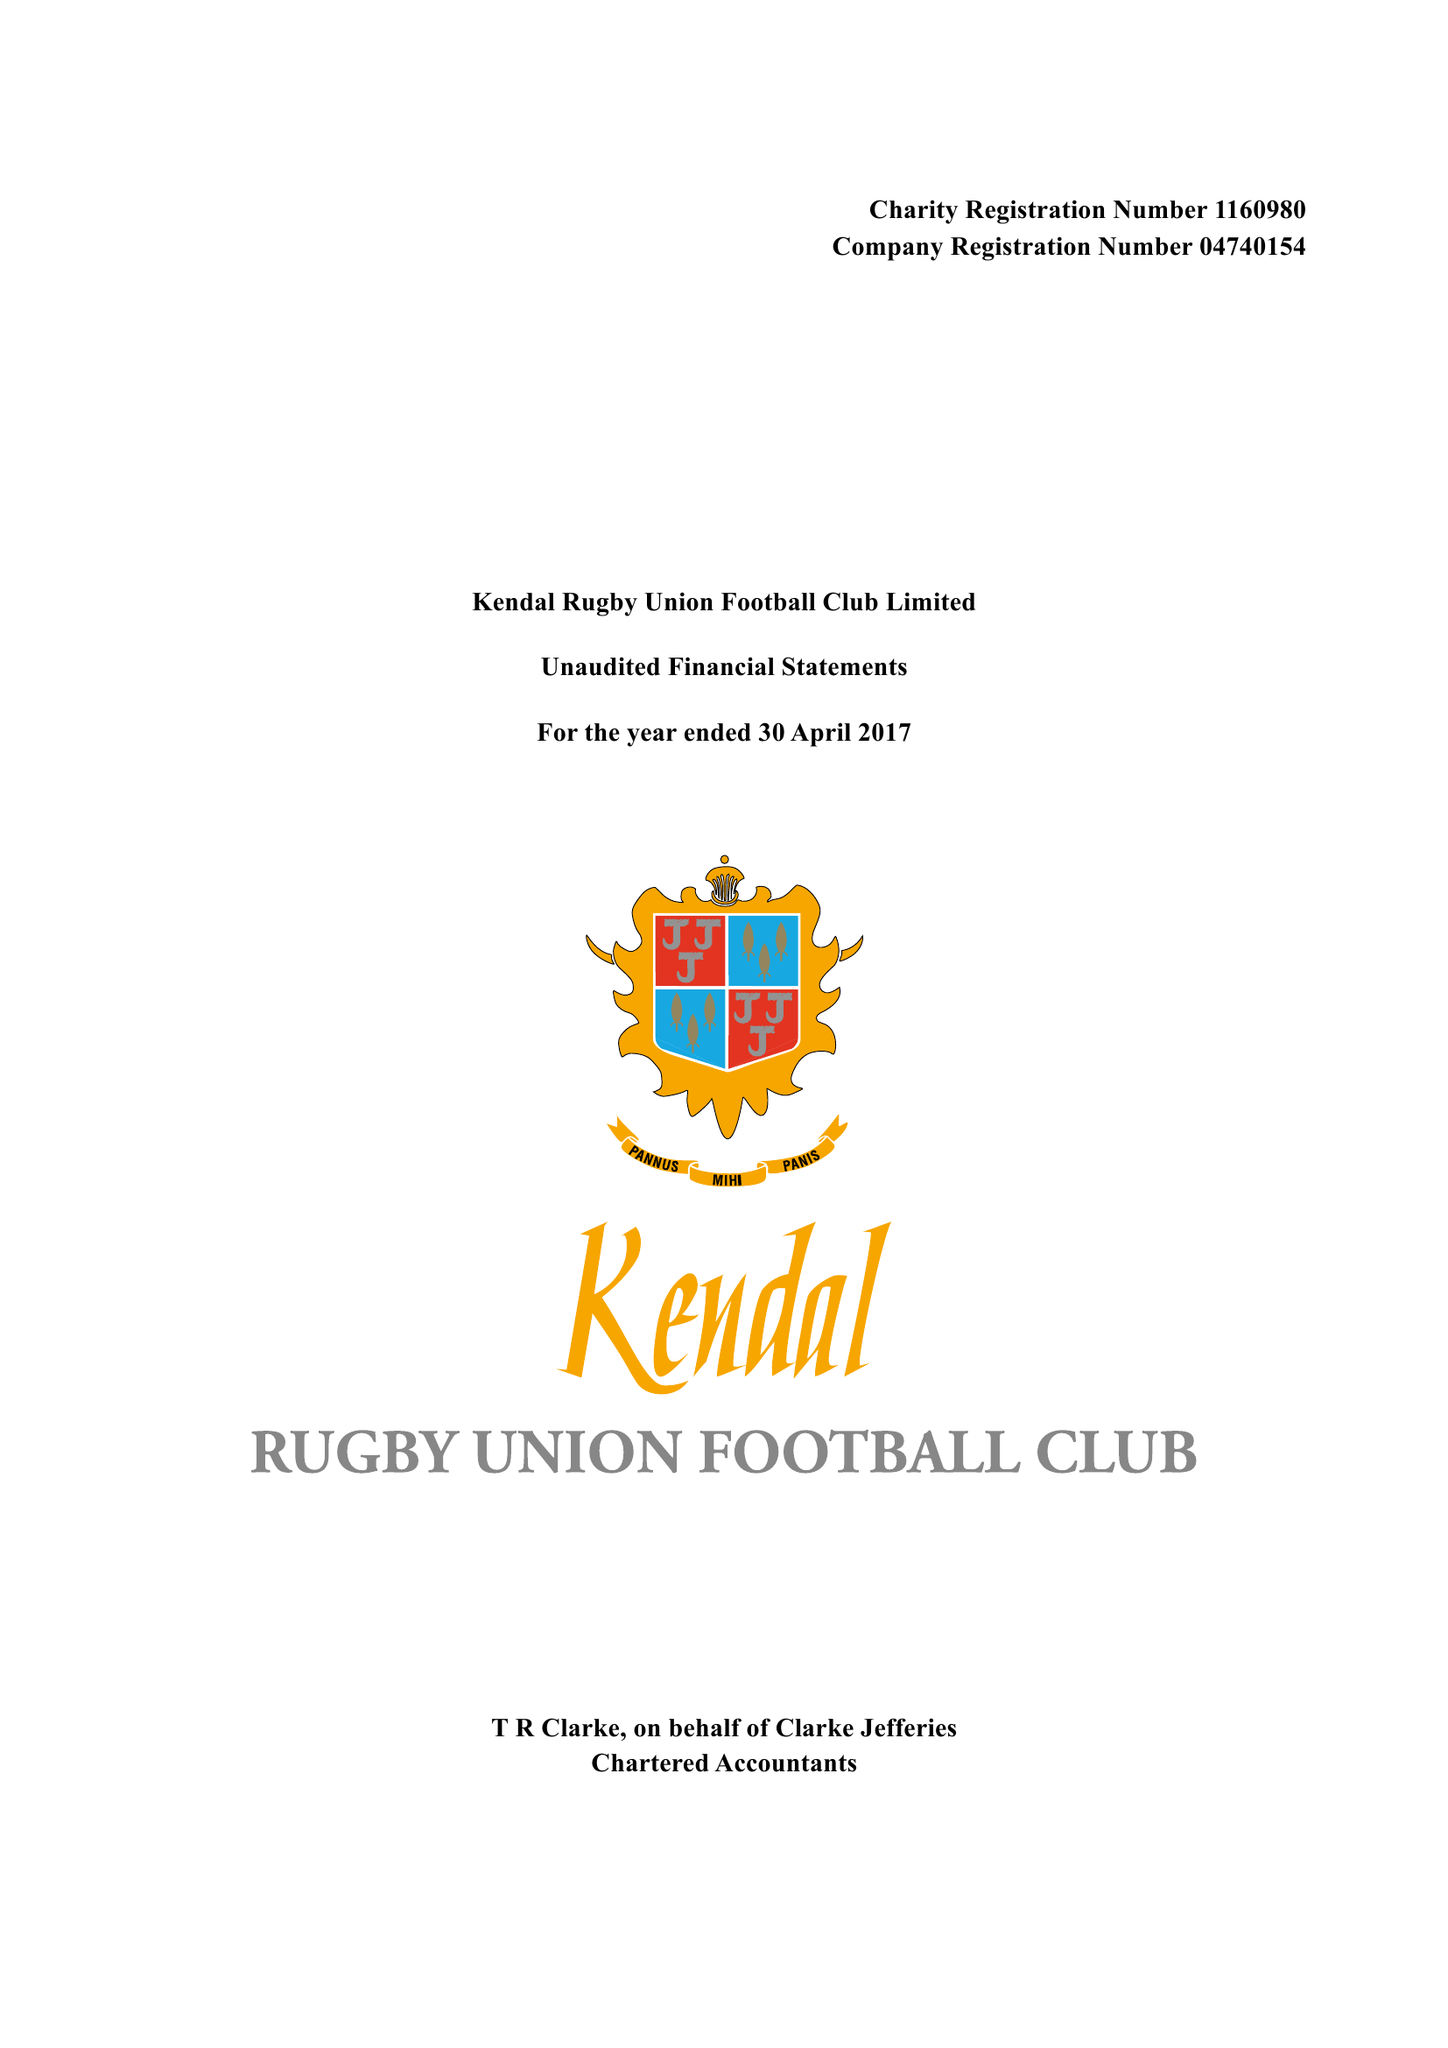What is the value for the charity_name?
Answer the question using a single word or phrase. Kendal Rugby Union Football Club Ltd. 